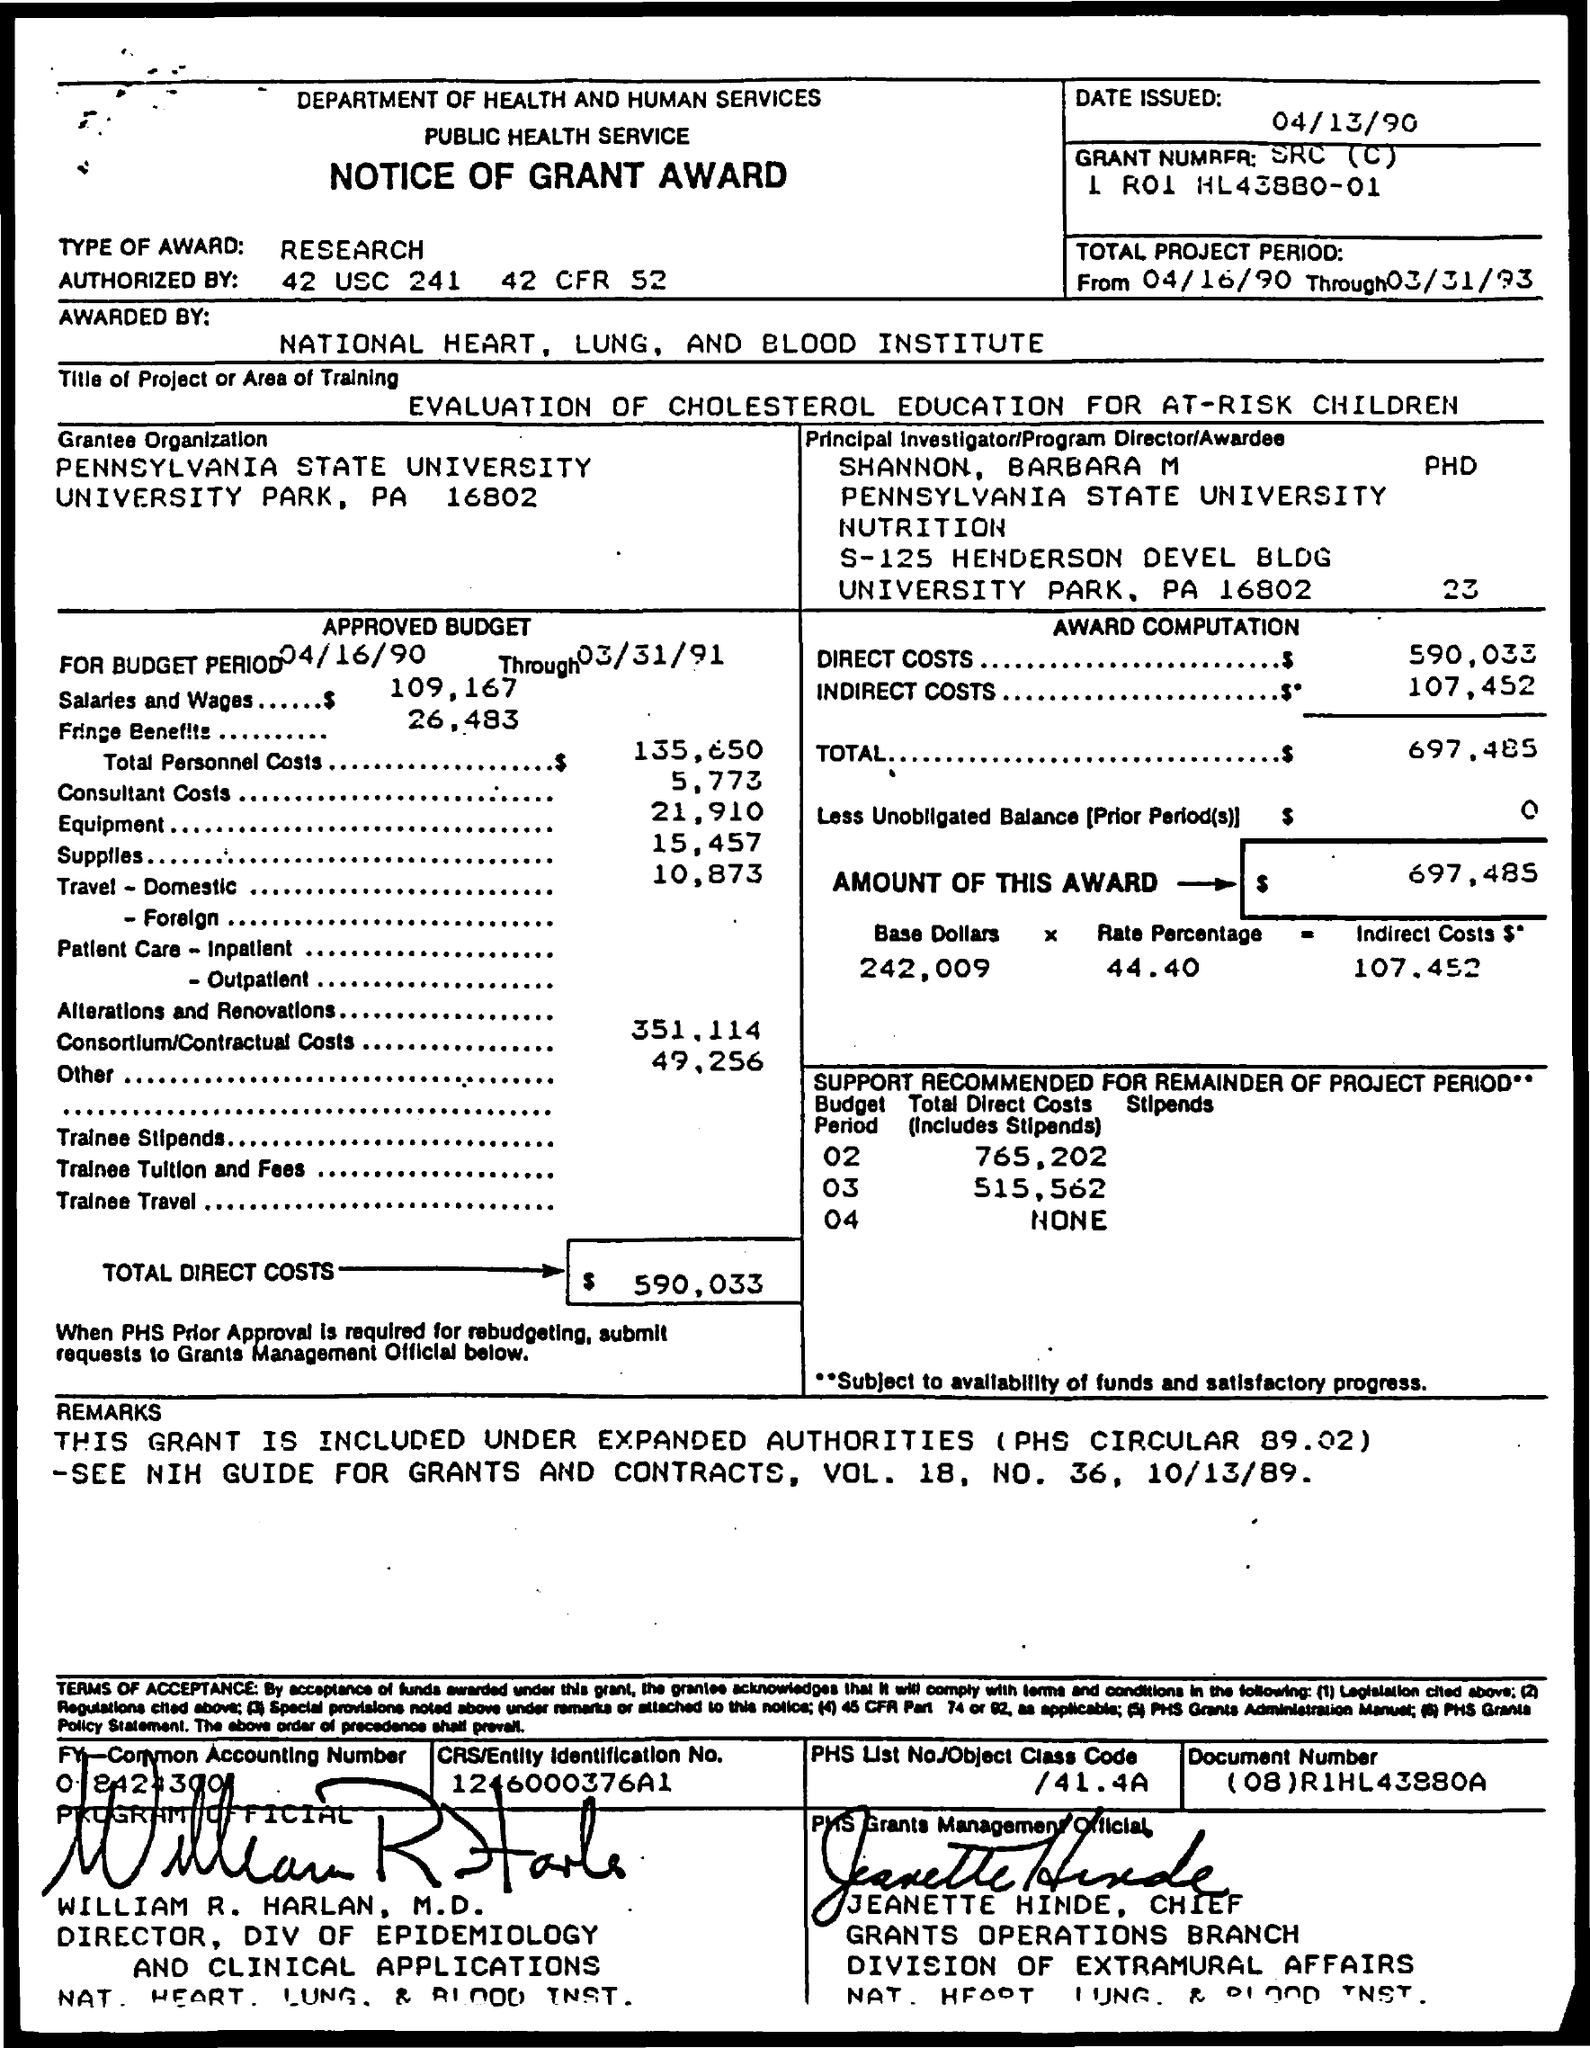What is the Type of Award?
Provide a short and direct response. Research. What are the Direct Costs?
Offer a very short reply. 590,033. What are the InDirect Costs?
Your answer should be very brief. 107,452. What is the amount of this award?
Your answer should be compact. $697,485. Who is it Authorized by?
Offer a terse response. 42 USC 241 42 CFR 52. What is the Total Project Period?
Make the answer very short. From 04/16/90 through 03/31/93. 